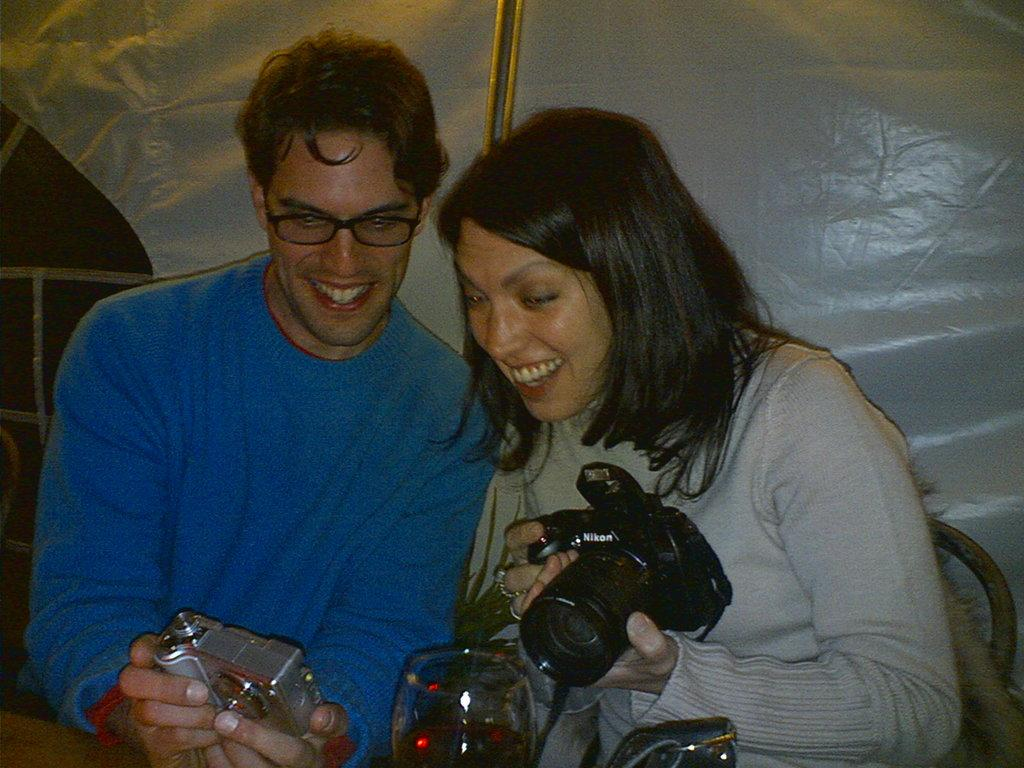How many people are in the image? There are two persons in the image. What are the two persons doing in the image? Both persons are sitting on a chair and holding a camera. Can you describe the clothing of the two persons? One person is wearing a blue t-shirt, and the other person is wearing an ash t-shirt. What object is placed in front of the two persons? There is a glass in front of the two persons. What is the payment method used by the person wearing the blue t-shirt in the image? There is no information about payment methods in the image; it only shows two persons sitting on a chair, holding a camera, and wearing different colored t-shirts. 